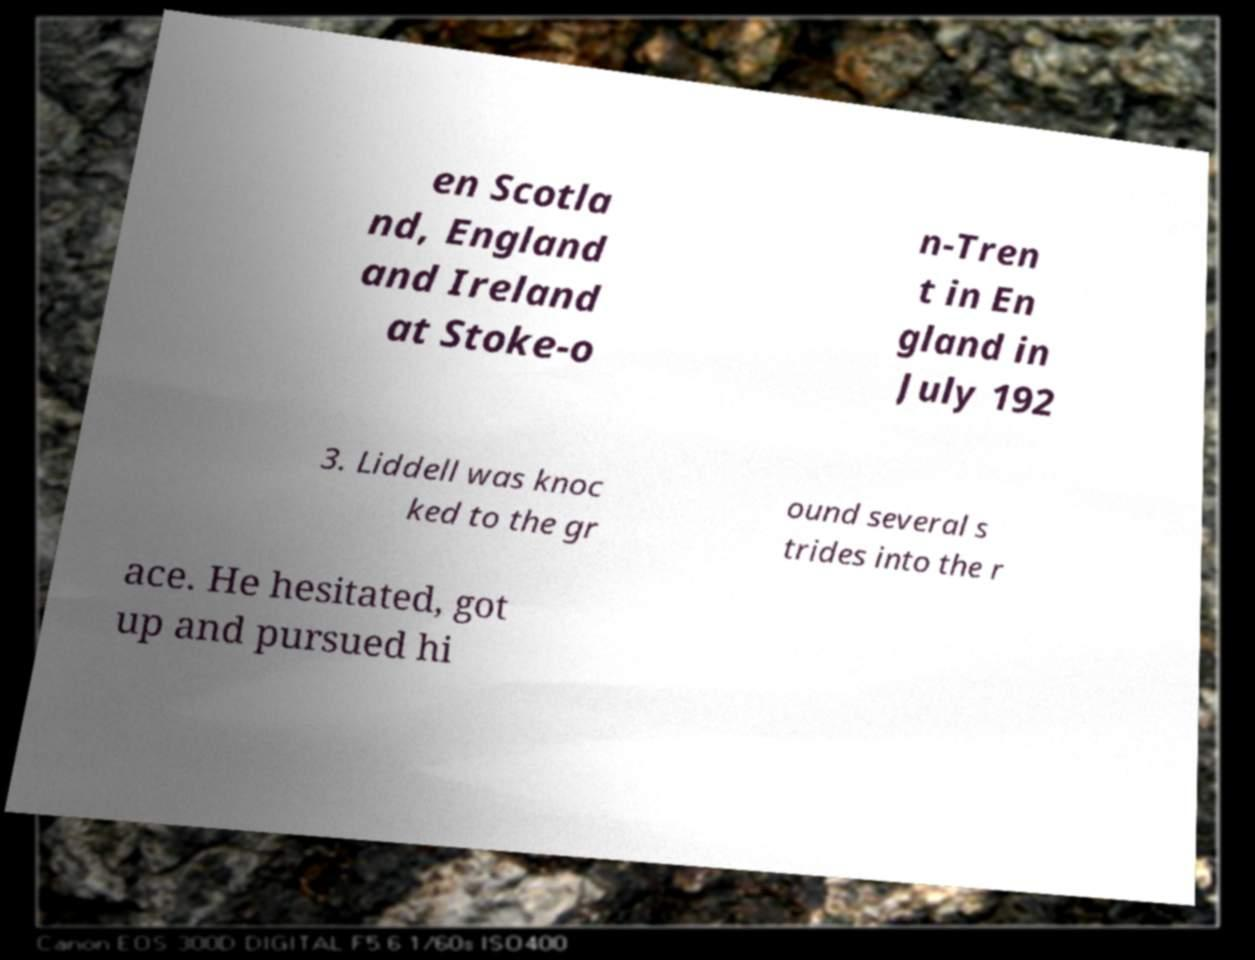Can you read and provide the text displayed in the image?This photo seems to have some interesting text. Can you extract and type it out for me? en Scotla nd, England and Ireland at Stoke-o n-Tren t in En gland in July 192 3. Liddell was knoc ked to the gr ound several s trides into the r ace. He hesitated, got up and pursued hi 